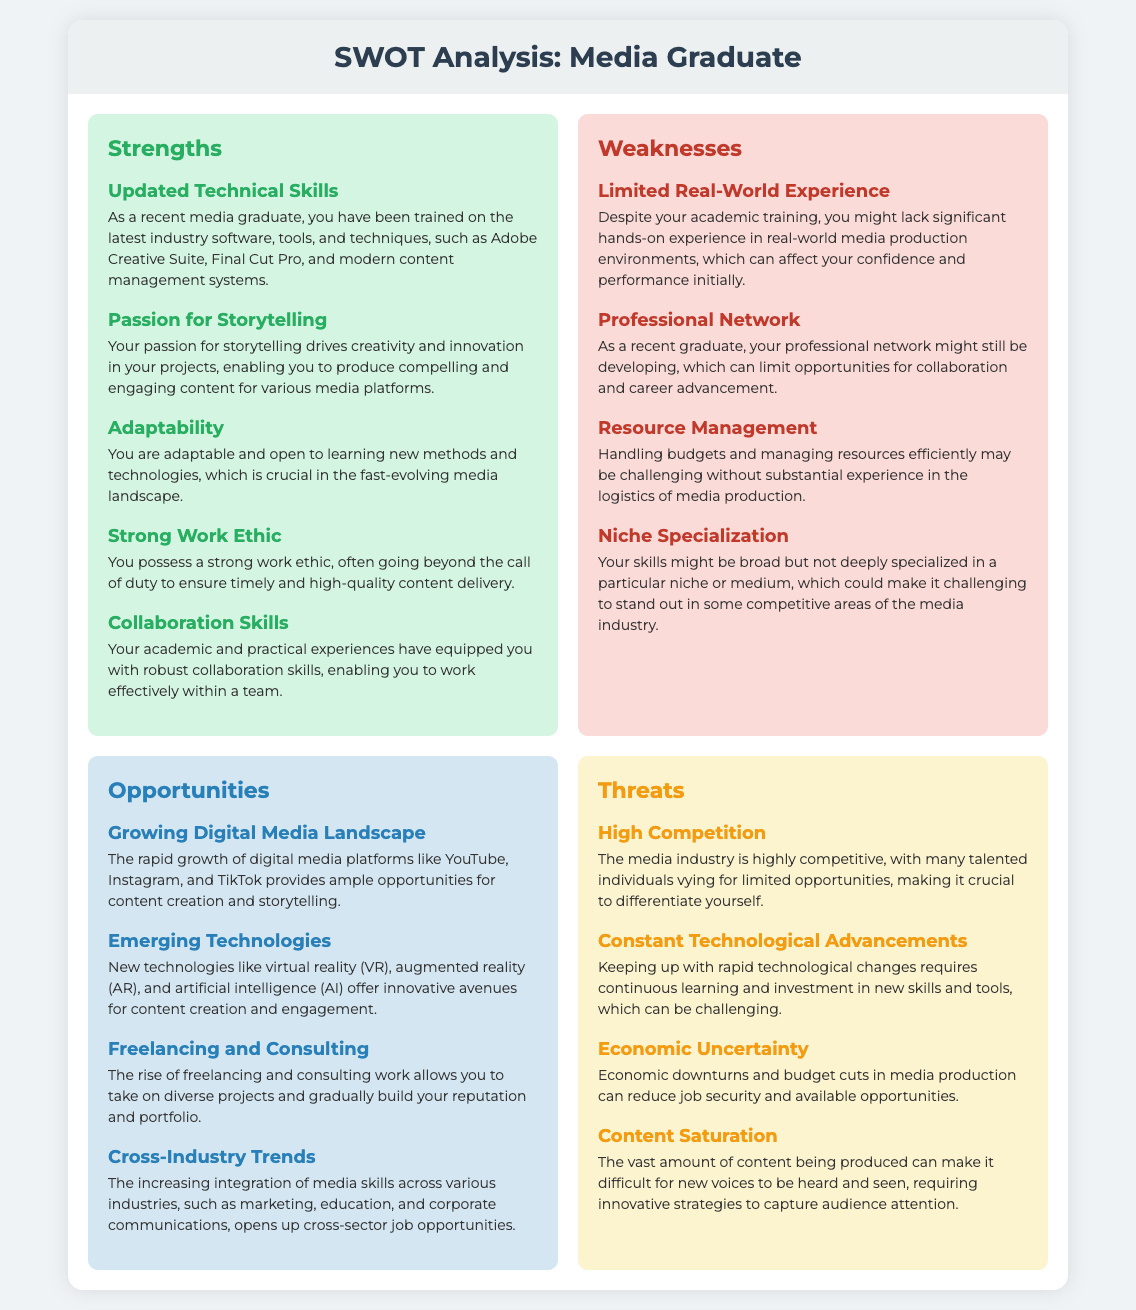What is a strength related to storytelling? One of the strengths mentioned is a passion for storytelling, which drives creativity and innovation.
Answer: Passion for Storytelling How many weaknesses are listed in the document? The document lists four weaknesses concerning a media graduate's personal branding.
Answer: Four What is a specific technology mentioned in the opportunities section? One of the emerging technologies highlighted is virtual reality (VR), which offers innovative avenues for content creation.
Answer: Virtual reality What contributes to the strong work ethic mentioned? It indicates the tendency to go beyond the call of duty for high-quality content delivery.
Answer: Strong work ethic What is a threat related to job security? Economic uncertainty is noted as a threat that can reduce job security in media production.
Answer: Economic Uncertainty Which skill is associated with adaptability? Adaptability is linked to being open to learning new methods and technologies in a fast-evolving media landscape.
Answer: Open to learning What do emerging technologies provide, according to the opportunities section? Emerging technologies offer innovative avenues for content creation and engagement.
Answer: Innovative avenues What type of landscape is mentioned as an opportunity? The growing digital media landscape provides opportunities for content creation.
Answer: Digital media landscape 